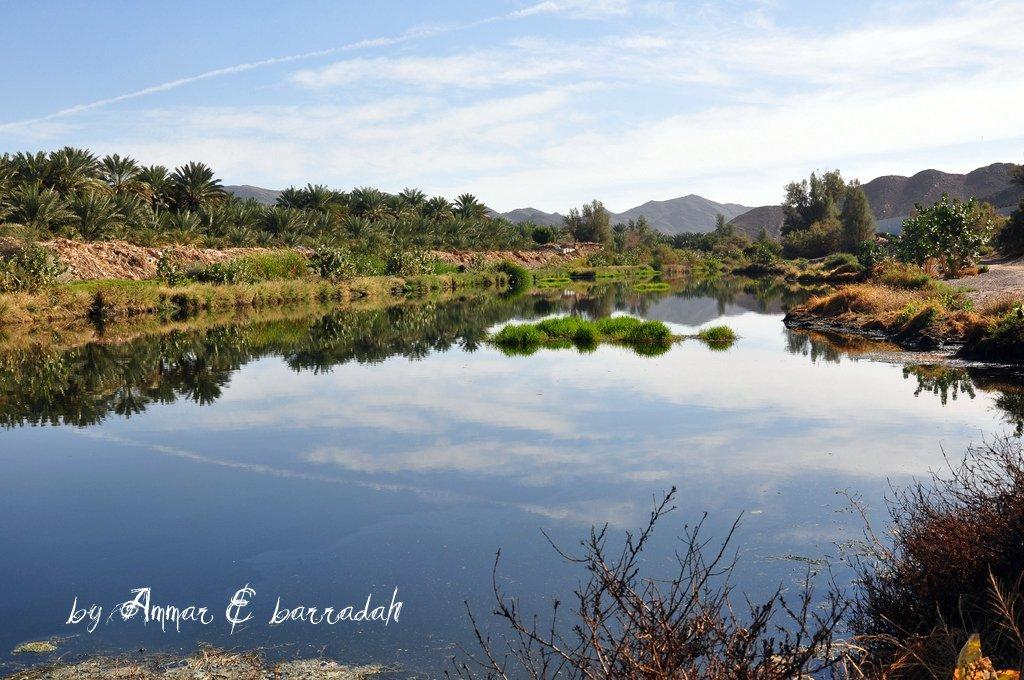What is the primary element visible in the image? There is water in the image. What other natural elements can be seen in the image? There are many plants and trees in the image, as well as hills in the background. What is visible in the background of the image? The sky is visible in the background of the image, with clouds present. Is there any indication of a watermark in the image? Yes, there is a watermark in the left bottom corner of the image. What type of cup can be seen floating in the water in the image? There is no cup visible in the water in the image. 